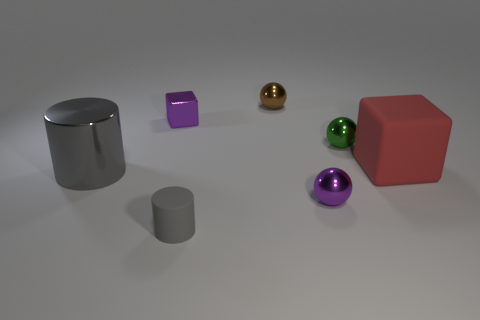Add 2 tiny purple shiny cubes. How many objects exist? 9 Subtract all green shiny balls. How many balls are left? 2 Subtract all purple blocks. How many blocks are left? 1 Subtract 1 spheres. How many spheres are left? 2 Subtract all blue cylinders. How many blue balls are left? 0 Subtract all big brown shiny cubes. Subtract all tiny objects. How many objects are left? 2 Add 5 gray cylinders. How many gray cylinders are left? 7 Add 4 large metal cylinders. How many large metal cylinders exist? 5 Subtract 0 blue spheres. How many objects are left? 7 Subtract all cubes. How many objects are left? 5 